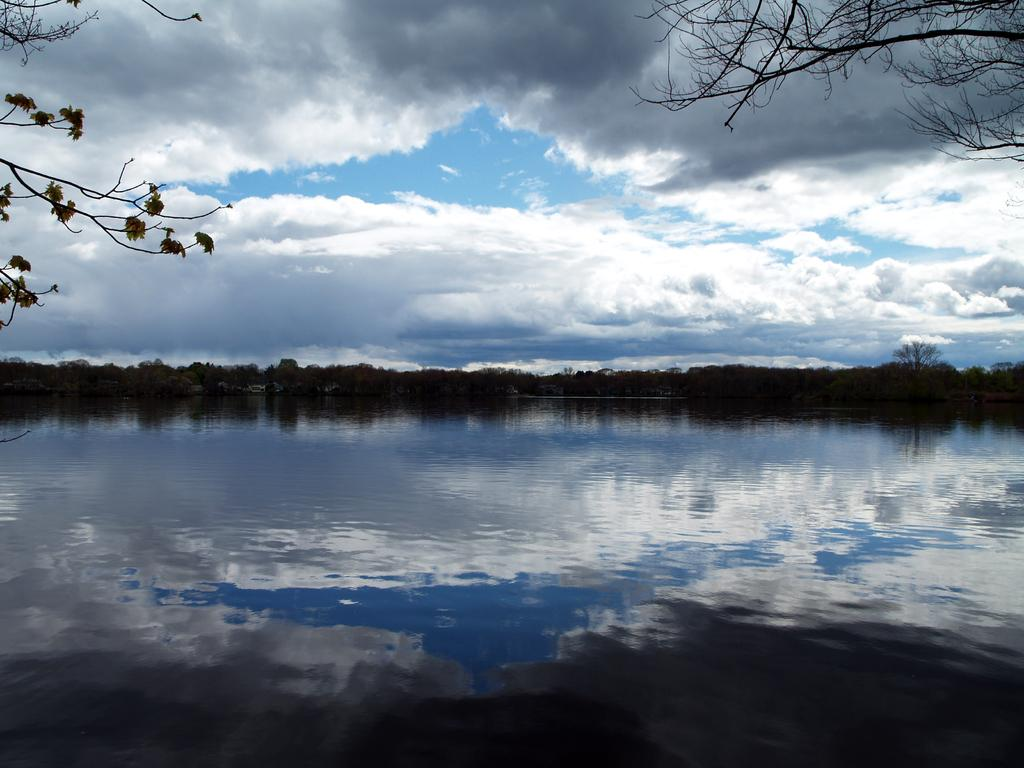What type of view is shown in the image? The image is an outside view. What natural feature can be seen at the bottom of the image? There is a sea at the bottom of the image. What type of vegetation is visible in the background of the image? There are many trees in the background of the image. What part of the natural environment is visible at the top of the image? The sky is visible at the top of the image. What can be observed in the sky in the image? Clouds are present in the sky. What time of day is it in the image, and where is the lunchroom located? The time of day cannot be determined from the image, and there is no mention of a lunchroom in the provided facts. 